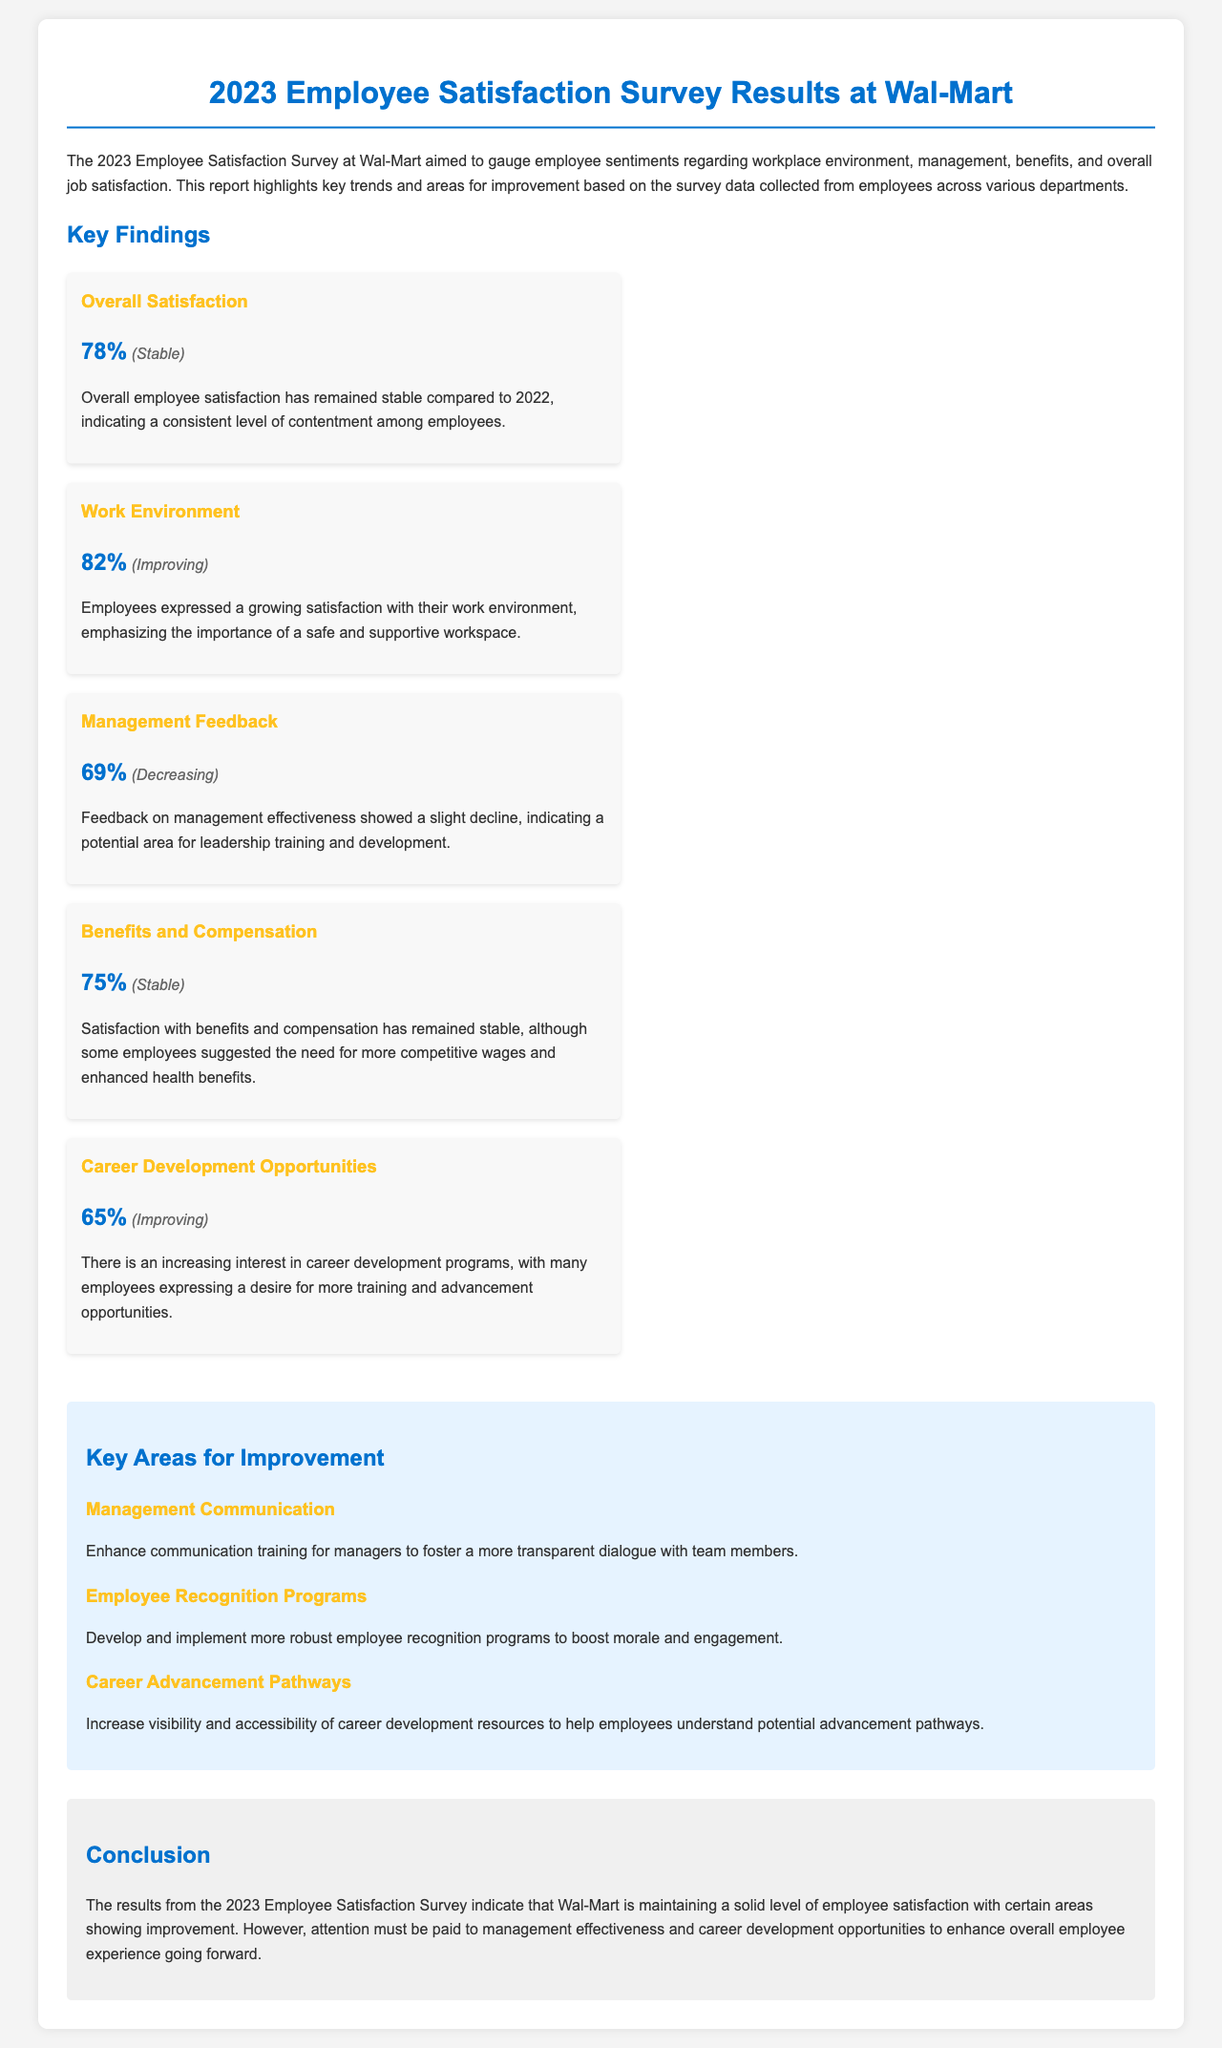what was the overall employee satisfaction percentage? The overall employee satisfaction percentage is indicated in the findings section of the document.
Answer: 78% what trend is associated with the work environment satisfaction? The trend for work environment satisfaction is mentioned alongside its percentage in the findings.
Answer: Improving what percentage of employees are satisfied with benefits and compensation? The percentage indicating satisfaction with benefits and compensation can be found in the report's key findings.
Answer: 75% which area of employee satisfaction showed a decrease in feedback? The area with decreasing feedback is specified in the findings section.
Answer: Management Feedback what is one key area for improvement mentioned in the report? The report outlines specific areas needing improvement, one of which is included in the sections detailing key areas for enhancement.
Answer: Management Communication how many employees expressed a desire for more training and advancement opportunities? The level of interest in career development programs can be interpreted from the career development findings.
Answer: 65% what conclusion can be drawn regarding employee satisfaction and management effectiveness? The conclusion synthesizes the findings related to employee satisfaction levels and management effectiveness.
Answer: Attention must be paid to management effectiveness what type of programs are suggested to boost employee morale? Suggestions for specific program types are listed in the areas for improvement section of the report.
Answer: Employee Recognition Programs 